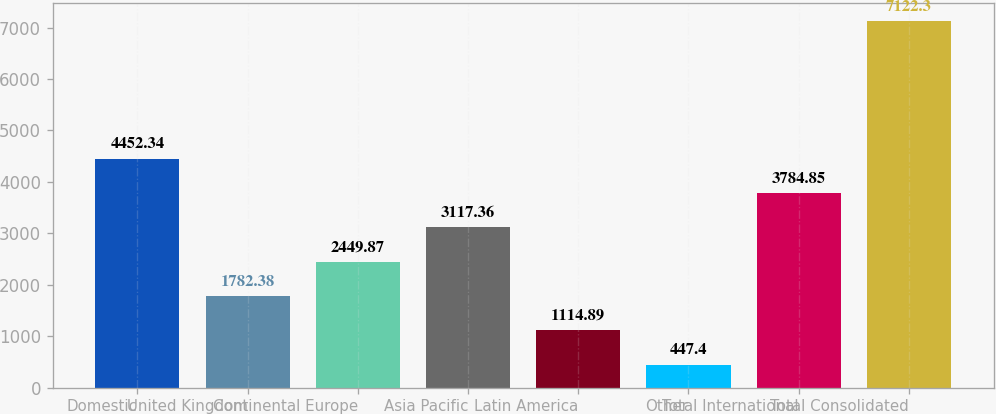Convert chart. <chart><loc_0><loc_0><loc_500><loc_500><bar_chart><fcel>Domestic<fcel>United Kingdom<fcel>Continental Europe<fcel>Asia Pacific<fcel>Latin America<fcel>Other<fcel>Total International<fcel>Total Consolidated<nl><fcel>4452.34<fcel>1782.38<fcel>2449.87<fcel>3117.36<fcel>1114.89<fcel>447.4<fcel>3784.85<fcel>7122.3<nl></chart> 